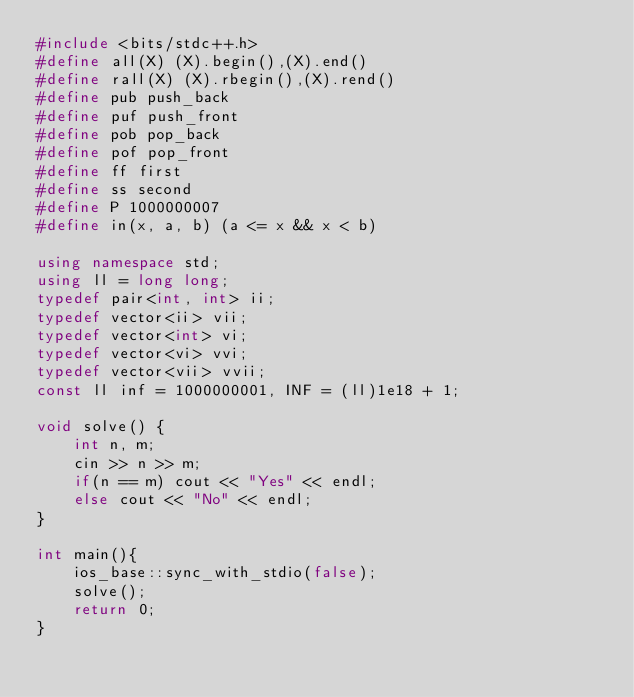Convert code to text. <code><loc_0><loc_0><loc_500><loc_500><_C++_>#include <bits/stdc++.h>
#define all(X) (X).begin(),(X).end()
#define rall(X) (X).rbegin(),(X).rend()
#define pub push_back
#define puf push_front
#define pob pop_back
#define pof pop_front
#define ff first
#define ss second
#define P 1000000007
#define in(x, a, b) (a <= x && x < b)

using namespace std;
using ll = long long;
typedef pair<int, int> ii;
typedef vector<ii> vii; 
typedef vector<int> vi;
typedef vector<vi> vvi;
typedef vector<vii> vvii;
const ll inf = 1000000001, INF = (ll)1e18 + 1;

void solve() {
	int n, m;
	cin >> n >> m;
	if(n == m) cout << "Yes" << endl;
	else cout << "No" << endl;
}

int main(){
	ios_base::sync_with_stdio(false);
	solve();
    return 0;
}</code> 